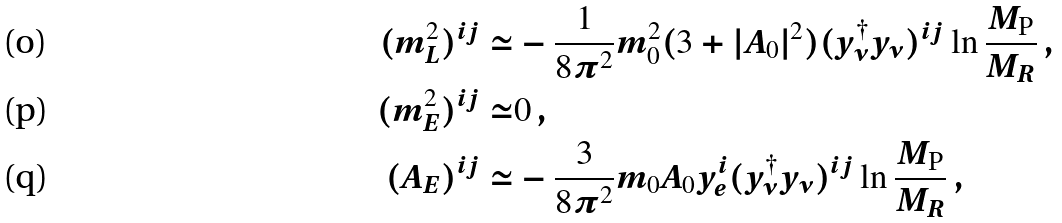<formula> <loc_0><loc_0><loc_500><loc_500>( m _ { L } ^ { 2 } ) ^ { i j } \simeq & - \frac { 1 } { 8 \pi ^ { 2 } } m _ { 0 } ^ { 2 } ( 3 + | A _ { 0 } | ^ { 2 } ) ( y _ { \nu } ^ { \dagger } y _ { \nu } ) ^ { i j } \ln \frac { M _ { \text {P} } } { M _ { R } } \, , \\ ( m _ { E } ^ { 2 } ) ^ { i j } \simeq & 0 \, , \\ ( A _ { E } ) ^ { i j } \simeq & - \frac { 3 } { 8 \pi ^ { 2 } } m _ { 0 } A _ { 0 } y _ { e } ^ { i } ( y _ { \nu } ^ { \dagger } y _ { \nu } ) ^ { i j } \ln \frac { M _ { \text {P} } } { M _ { R } } \, ,</formula> 